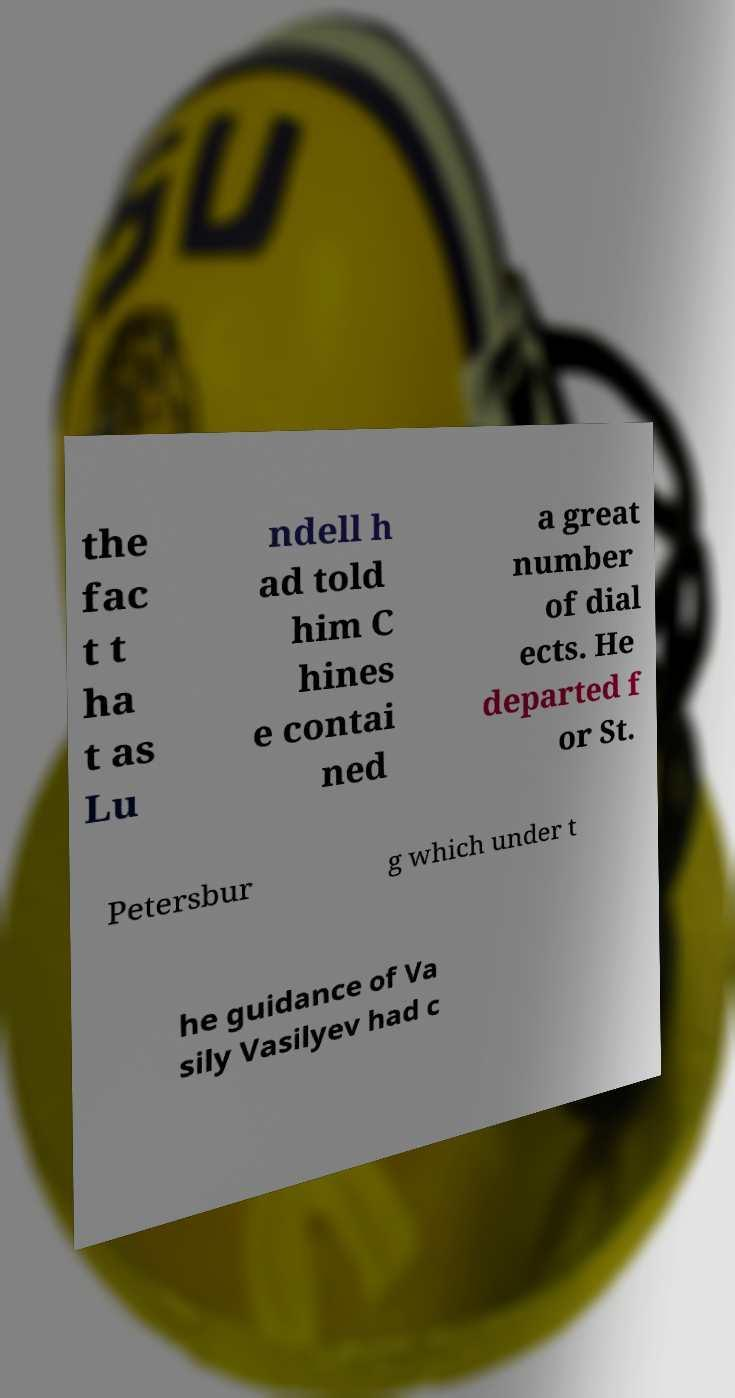Could you assist in decoding the text presented in this image and type it out clearly? the fac t t ha t as Lu ndell h ad told him C hines e contai ned a great number of dial ects. He departed f or St. Petersbur g which under t he guidance of Va sily Vasilyev had c 